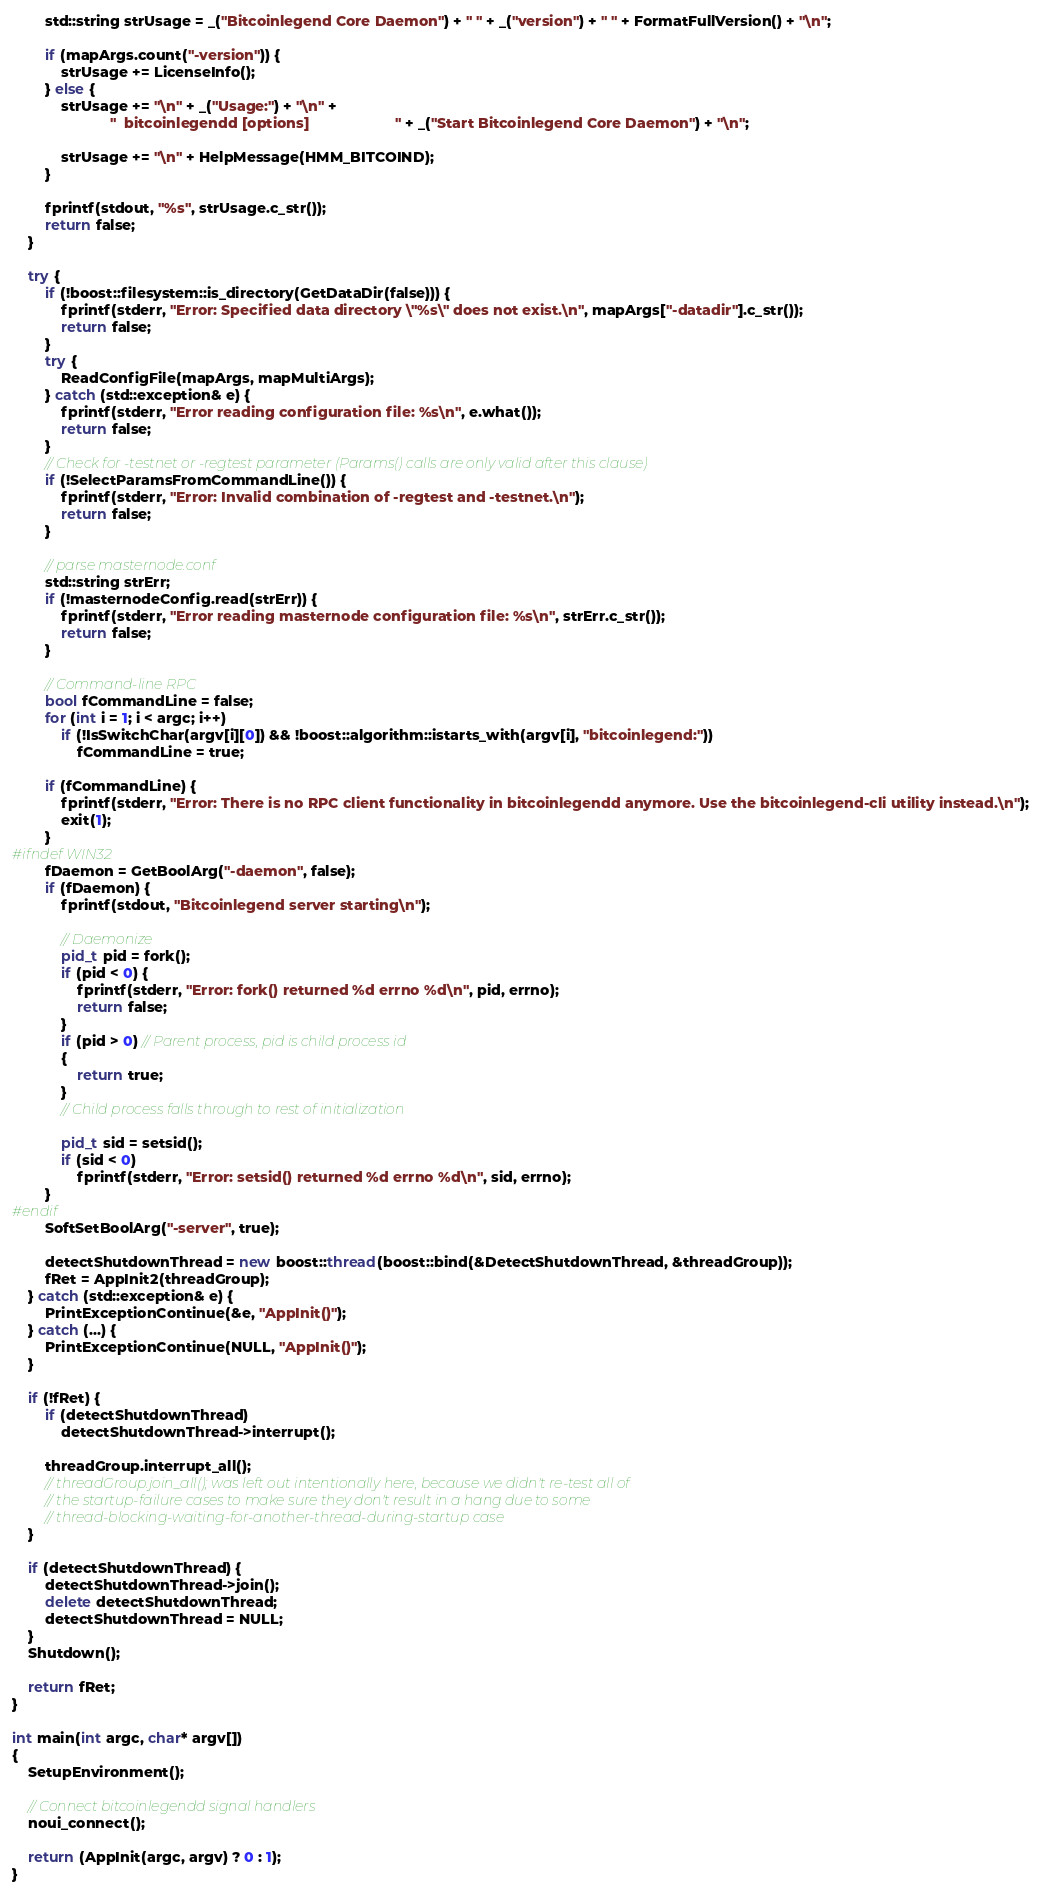Convert code to text. <code><loc_0><loc_0><loc_500><loc_500><_C++_>        std::string strUsage = _("Bitcoinlegend Core Daemon") + " " + _("version") + " " + FormatFullVersion() + "\n";

        if (mapArgs.count("-version")) {
            strUsage += LicenseInfo();
        } else {
            strUsage += "\n" + _("Usage:") + "\n" +
                        "  bitcoinlegendd [options]                     " + _("Start Bitcoinlegend Core Daemon") + "\n";

            strUsage += "\n" + HelpMessage(HMM_BITCOIND);
        }

        fprintf(stdout, "%s", strUsage.c_str());
        return false;
    }

    try {
        if (!boost::filesystem::is_directory(GetDataDir(false))) {
            fprintf(stderr, "Error: Specified data directory \"%s\" does not exist.\n", mapArgs["-datadir"].c_str());
            return false;
        }
        try {
            ReadConfigFile(mapArgs, mapMultiArgs);
        } catch (std::exception& e) {
            fprintf(stderr, "Error reading configuration file: %s\n", e.what());
            return false;
        }
        // Check for -testnet or -regtest parameter (Params() calls are only valid after this clause)
        if (!SelectParamsFromCommandLine()) {
            fprintf(stderr, "Error: Invalid combination of -regtest and -testnet.\n");
            return false;
        }

        // parse masternode.conf
        std::string strErr;
        if (!masternodeConfig.read(strErr)) {
            fprintf(stderr, "Error reading masternode configuration file: %s\n", strErr.c_str());
            return false;
        }

        // Command-line RPC
        bool fCommandLine = false;
        for (int i = 1; i < argc; i++)
            if (!IsSwitchChar(argv[i][0]) && !boost::algorithm::istarts_with(argv[i], "bitcoinlegend:"))
                fCommandLine = true;

        if (fCommandLine) {
            fprintf(stderr, "Error: There is no RPC client functionality in bitcoinlegendd anymore. Use the bitcoinlegend-cli utility instead.\n");
            exit(1);
        }
#ifndef WIN32
        fDaemon = GetBoolArg("-daemon", false);
        if (fDaemon) {
            fprintf(stdout, "Bitcoinlegend server starting\n");

            // Daemonize
            pid_t pid = fork();
            if (pid < 0) {
                fprintf(stderr, "Error: fork() returned %d errno %d\n", pid, errno);
                return false;
            }
            if (pid > 0) // Parent process, pid is child process id
            {
                return true;
            }
            // Child process falls through to rest of initialization

            pid_t sid = setsid();
            if (sid < 0)
                fprintf(stderr, "Error: setsid() returned %d errno %d\n", sid, errno);
        }
#endif
        SoftSetBoolArg("-server", true);

        detectShutdownThread = new boost::thread(boost::bind(&DetectShutdownThread, &threadGroup));
        fRet = AppInit2(threadGroup);
    } catch (std::exception& e) {
        PrintExceptionContinue(&e, "AppInit()");
    } catch (...) {
        PrintExceptionContinue(NULL, "AppInit()");
    }

    if (!fRet) {
        if (detectShutdownThread)
            detectShutdownThread->interrupt();

        threadGroup.interrupt_all();
        // threadGroup.join_all(); was left out intentionally here, because we didn't re-test all of
        // the startup-failure cases to make sure they don't result in a hang due to some
        // thread-blocking-waiting-for-another-thread-during-startup case
    }

    if (detectShutdownThread) {
        detectShutdownThread->join();
        delete detectShutdownThread;
        detectShutdownThread = NULL;
    }
    Shutdown();

    return fRet;
}

int main(int argc, char* argv[])
{
    SetupEnvironment();

    // Connect bitcoinlegendd signal handlers
    noui_connect();

    return (AppInit(argc, argv) ? 0 : 1);
}
</code> 